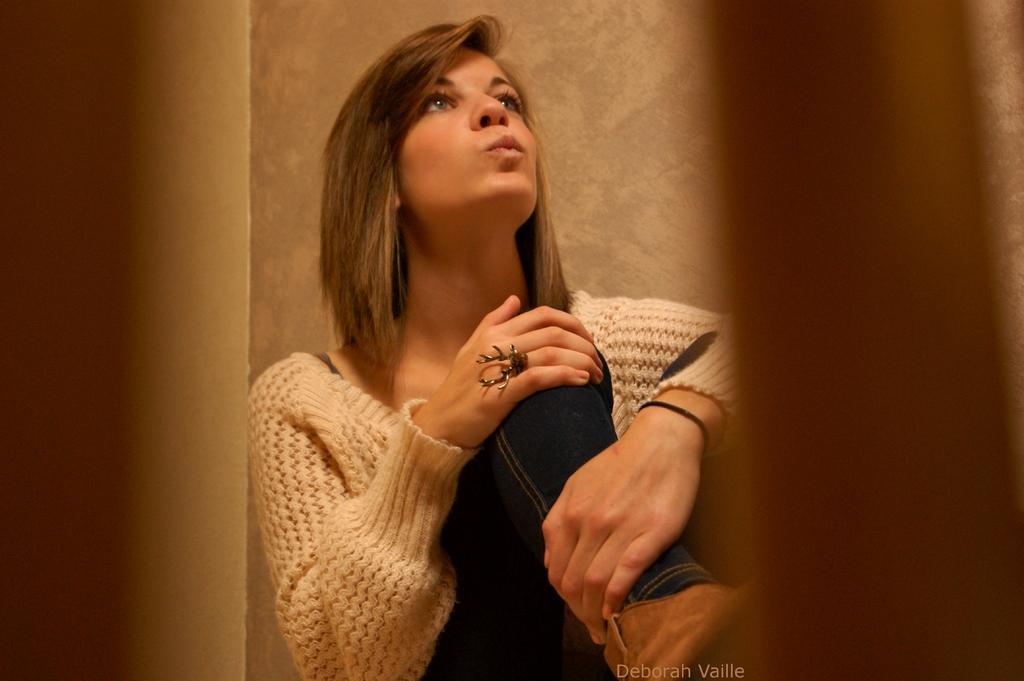Please provide a concise description of this image. In this image I can see a woman is sitting. The woman is wearing a sweater and a pant. In the background I can see a wall. 